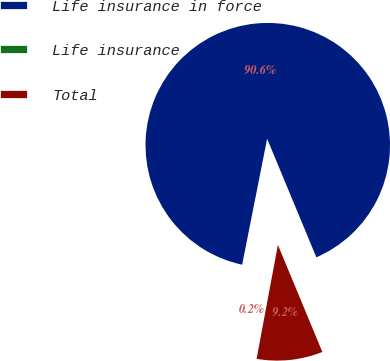<chart> <loc_0><loc_0><loc_500><loc_500><pie_chart><fcel>Life insurance in force<fcel>Life insurance<fcel>Total<nl><fcel>90.62%<fcel>0.17%<fcel>9.21%<nl></chart> 